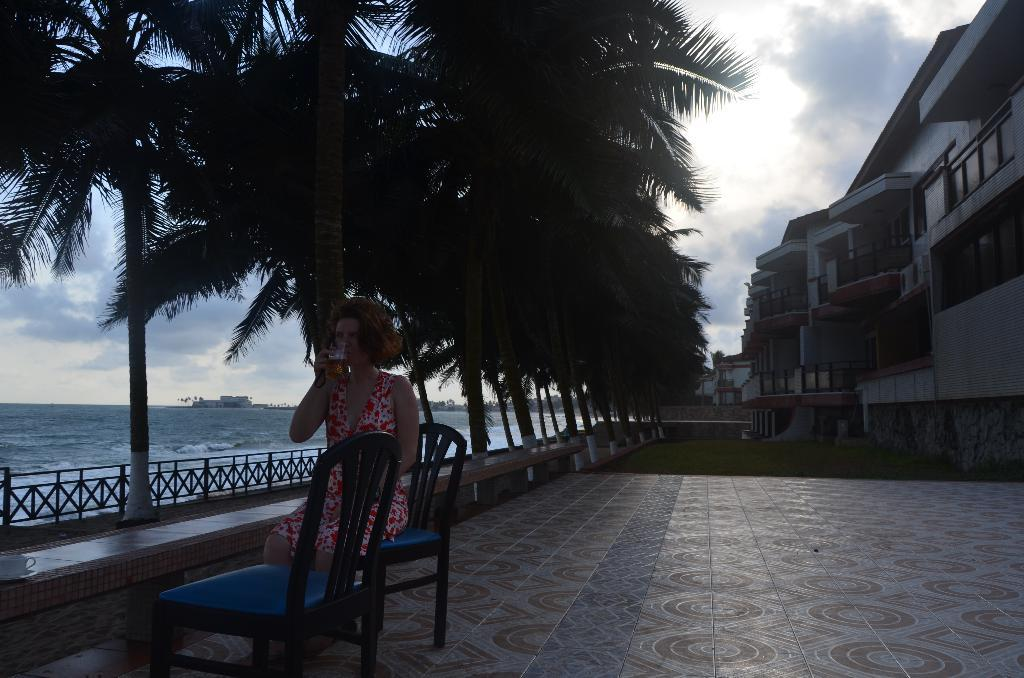Who is present in the image? There is a lady in the image. What is the lady wearing? The lady is wearing a floral dress. What is the lady doing in the image? The lady is sitting on a chair and drinking from a glass. Is there another chair in the image? Yes, there is another chair next to the lady. What can be seen in the background of the image? There are buildings, trees, sky, and water visible in the background of the image. What type of prose is the lady reading in the image? There is no book or any indication of reading in the image. 